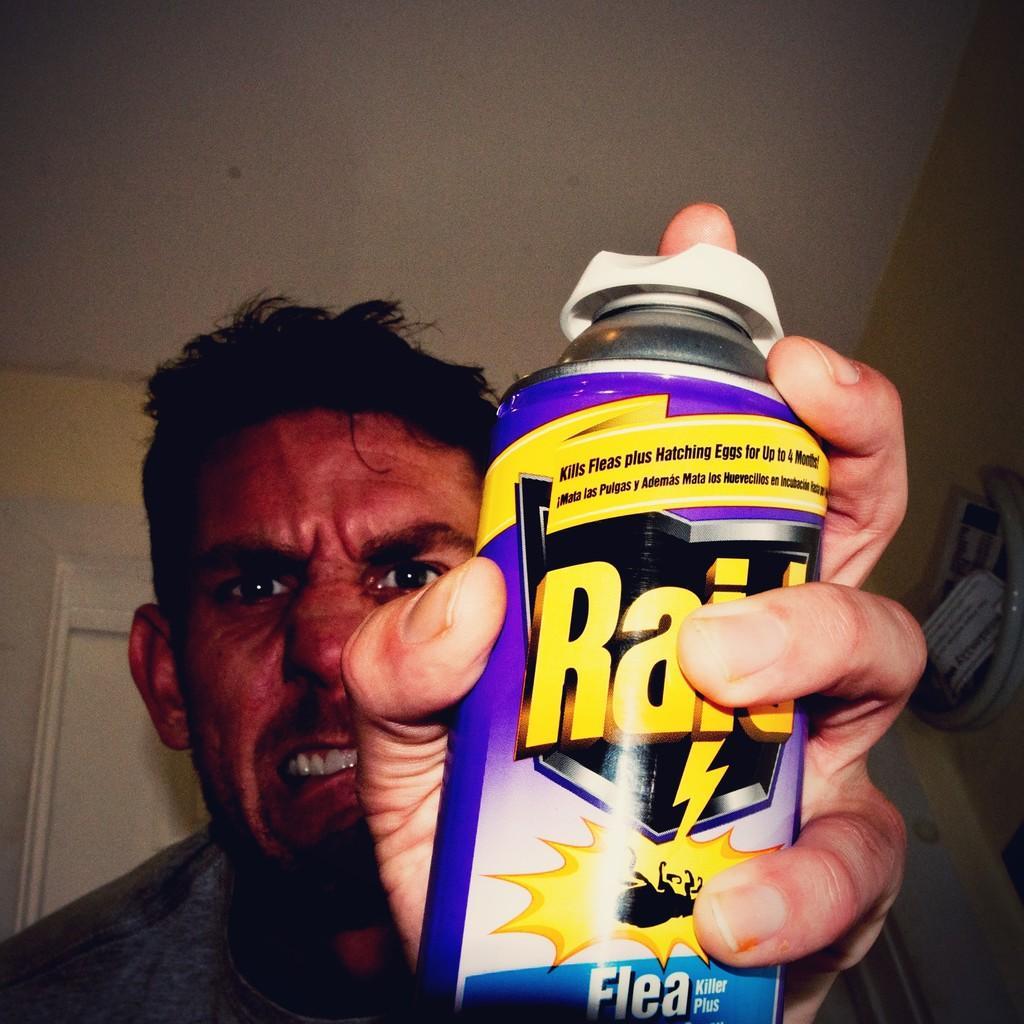Can you describe this image briefly? In the image a person is holding a tin. Behind him we can see a wall. At the top of the image we can see the ceiling. 